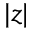<formula> <loc_0><loc_0><loc_500><loc_500>| z |</formula> 